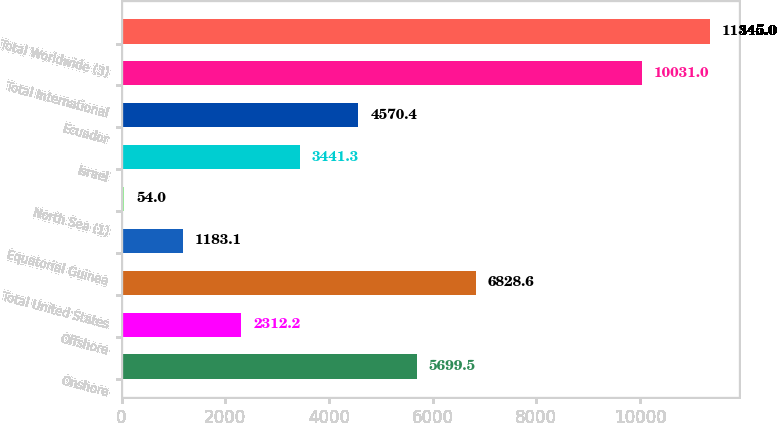Convert chart to OTSL. <chart><loc_0><loc_0><loc_500><loc_500><bar_chart><fcel>Onshore<fcel>Offshore<fcel>Total United States<fcel>Equatorial Guinea<fcel>North Sea (1)<fcel>Israel<fcel>Ecuador<fcel>Total International<fcel>Total Worldwide (3)<nl><fcel>5699.5<fcel>2312.2<fcel>6828.6<fcel>1183.1<fcel>54<fcel>3441.3<fcel>4570.4<fcel>10031<fcel>11345<nl></chart> 